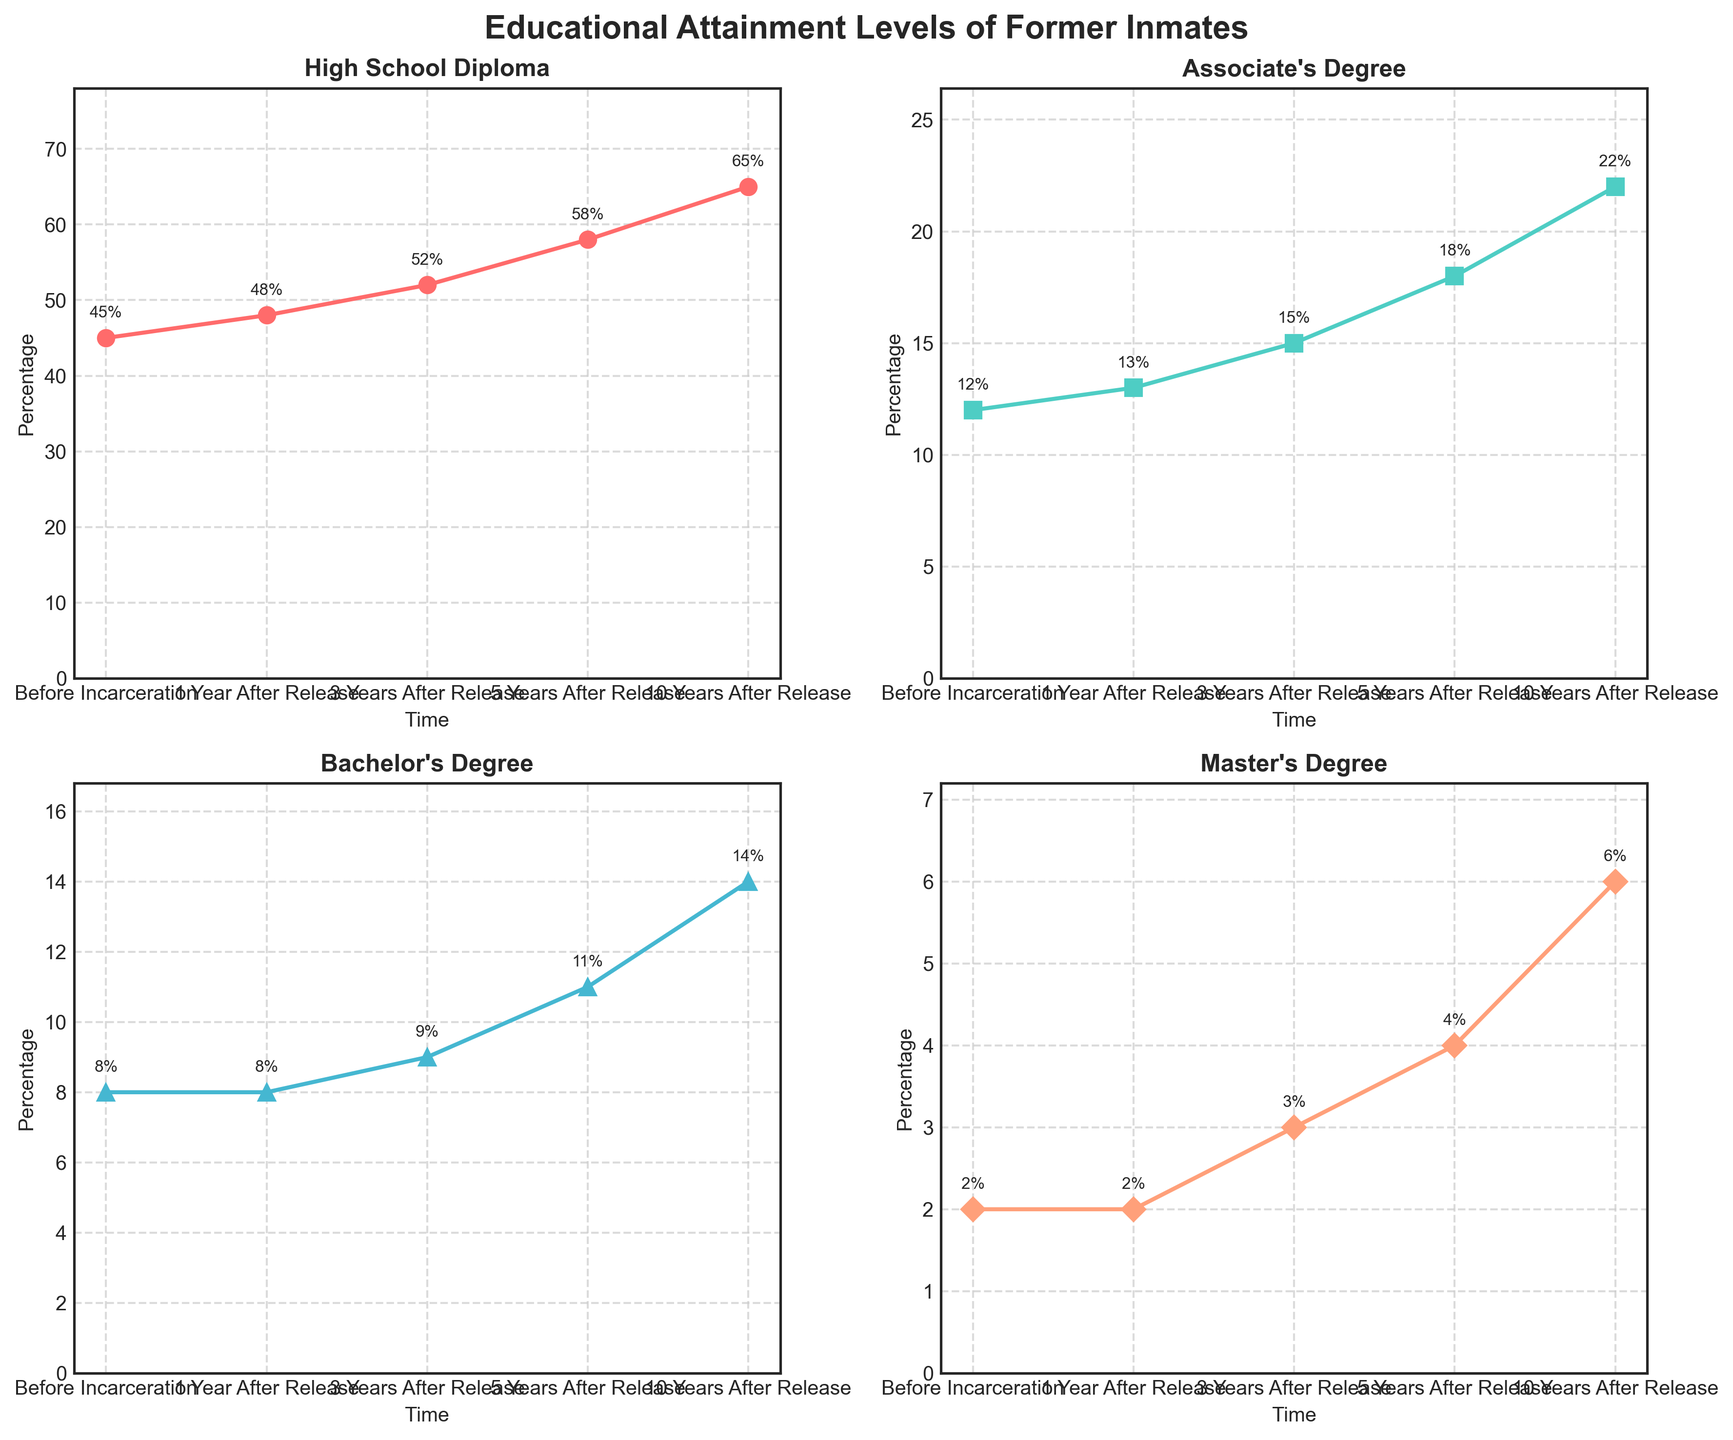What is the title of the figure? The title is located at the top of the figure and summarizes the contents or purpose of the plot. The title of the figure is "Educational Attainment Levels of Former Inmates".
Answer: Educational Attainment Levels of Former Inmates How many different degree types are shown in the subplots? The number of subplots corresponds to the number of degree types being depicted. There are four subplots, each titled with a different degree type.
Answer: 4 Which degree type had the highest percentage increase between 'Before Incarceration' and '10 Years After Release'? To find this, look at the data points for 'Before Incarceration' and '10 Years After Release' in each subplot and calculate the percentage increase. The biggest increase is for the High School Diploma, from 45% to 65%.
Answer: High School Diploma By how many percentage points did the Bachelor's Degree attainment level change from 'Before Incarceration' to '5 Years After Release'? Subtract the percentage of 'Before Incarceration' from the percentage of '5 Years After Release' for the Bachelor's Degree subplot: 11% (5 years after) - 8% (before) = 3 percentage points.
Answer: 3 percentage points Which degree type had the least improvement in attainment over the 10-year period? Compare the change in percentage for each degree type from 'Before Incarceration' to '10 Years After Release'. The Master's Degree had the least improvement, from 2% to 6%.
Answer: Master's Degree What was the percentage of individuals with an Associate's Degree 3 years after release? Look at the data point on the Associate's Degree subplot at '3 Years After Release'. The percentage is observed directly from the plot labels.
Answer: 15% How does the trend for High School Diploma compare to the trend for Master's Degree across the years? Compare the plots for High School Diploma and Master's Degree. High School Diploma shows a consistently increasing trend with a steeper slope, while Master's Degree also increases but at a more gradual pace.
Answer: High School Diploma increased more steeply Which degree type had the smallest percentage point increase from '1 Year After Release' to '3 Years After Release'? Calculate the percentage point increase for each degree type between these two time points and identify the smallest. The Bachelor's Degree had the smallest increase of 1 percentage point (8% to 9%).
Answer: Bachelor's Degree Which years had no change in the percentage for Bachelor's Degree attainment? Identify the time points for Bachelor's Degree where the percentage remained unchanged. The percentage was the same in 'Before Incarceration' and '1 Year After Release' (8%).
Answer: Before Incarceration, 1 Year After Release In which year did the percentage of individuals with a High School Diploma exceed 50%? Look at the High School Diploma subplot to see when the percentage crossed the 50% mark. This occurred '3 Years After Release'.
Answer: 3 Years After Release 